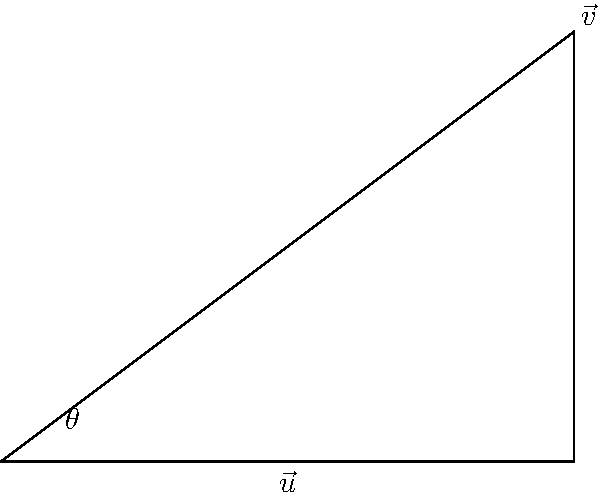In a study on the impact of cognitive-behavioral therapy (CBT) on overall anxiety levels, $\vec{v}$ represents the total anxiety vector, and $\vec{u}$ represents the specific impact of CBT. If $\|\vec{v}\| = 5$, $\|\vec{u}\| = 4$, and the angle between them is $\theta = 36.87°$, calculate the magnitude of the projection of $\vec{v}$ onto $\vec{u}$. This will help quantify how much of the overall anxiety is directly affected by the CBT intervention. To solve this problem, we'll use the formula for vector projection:

1) The magnitude of the projection of $\vec{v}$ onto $\vec{u}$ is given by:
   $\|\text{proj}_{\vec{u}}\vec{v}\| = \|\vec{v}\| \cos(\theta)$

2) We're given:
   $\|\vec{v}\| = 5$
   $\|\vec{u}\| = 4$ (not needed for this calculation)
   $\theta = 36.87°$

3) Substituting these values into the formula:
   $\|\text{proj}_{\vec{u}}\vec{v}\| = 5 \cos(36.87°)$

4) Using a calculator or computer:
   $\cos(36.87°) \approx 0.8$

5) Therefore:
   $\|\text{proj}_{\vec{u}}\vec{v}\| = 5 * 0.8 = 4$

This result indicates that 4 units of the overall anxiety vector are directly aligned with the CBT intervention vector, suggesting a substantial impact of CBT on overall anxiety levels.
Answer: $4$ 